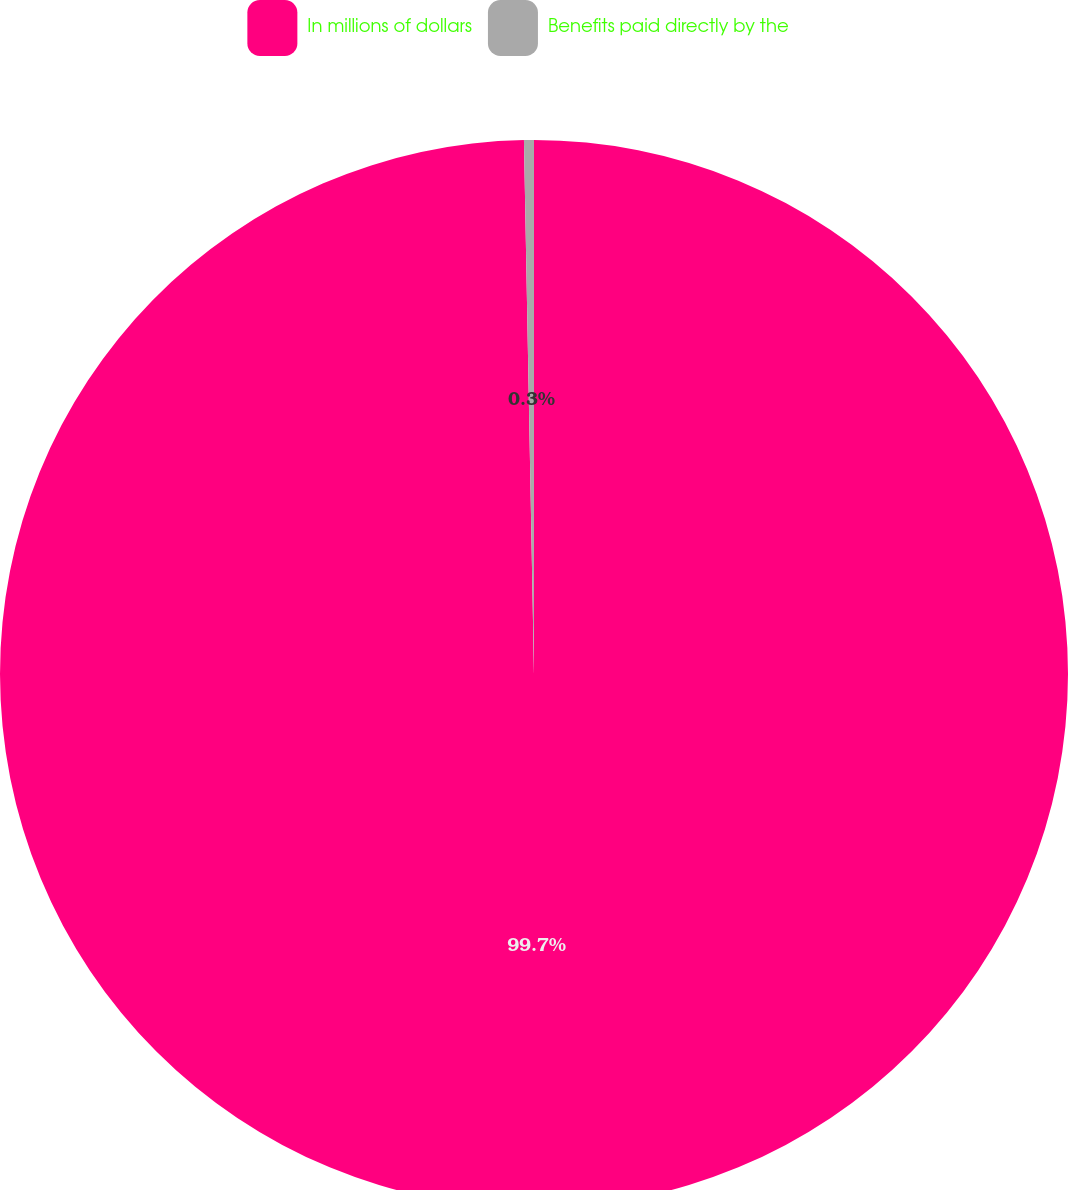<chart> <loc_0><loc_0><loc_500><loc_500><pie_chart><fcel>In millions of dollars<fcel>Benefits paid directly by the<nl><fcel>99.7%<fcel>0.3%<nl></chart> 